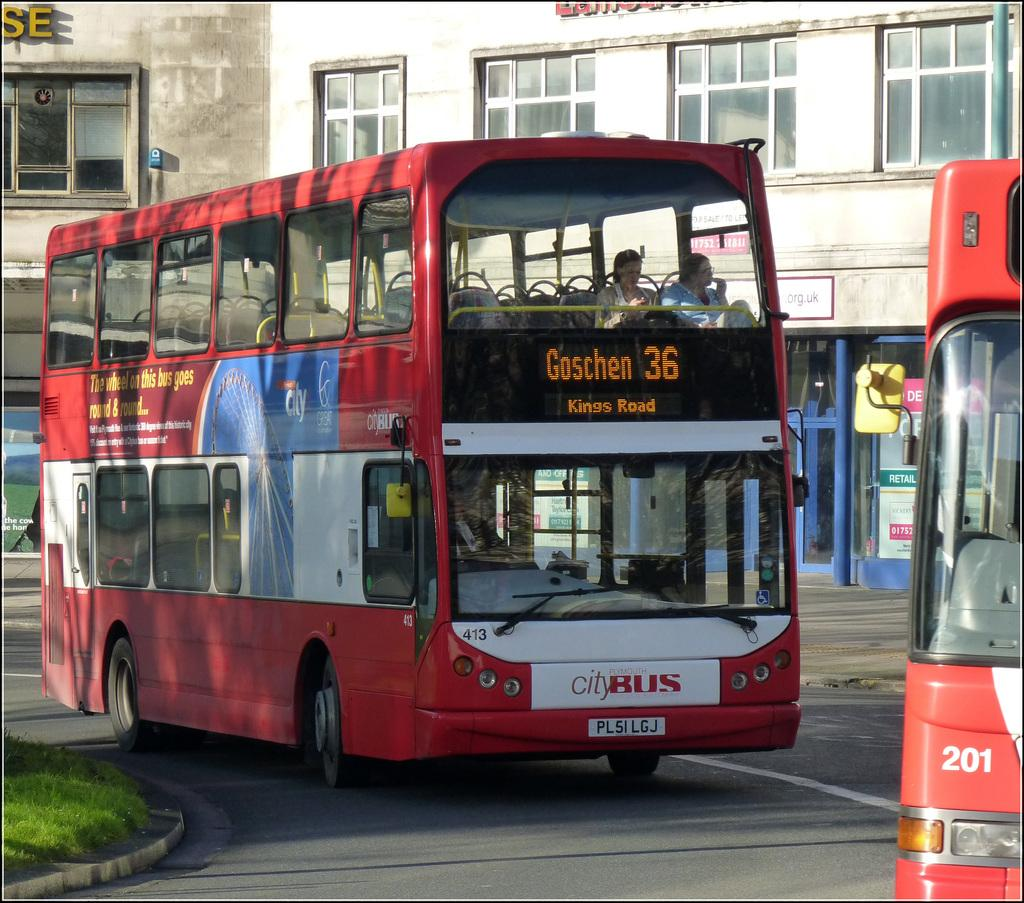Provide a one-sentence caption for the provided image. An ad on the bus reads, "The wheel on this bus goes round & round...". 